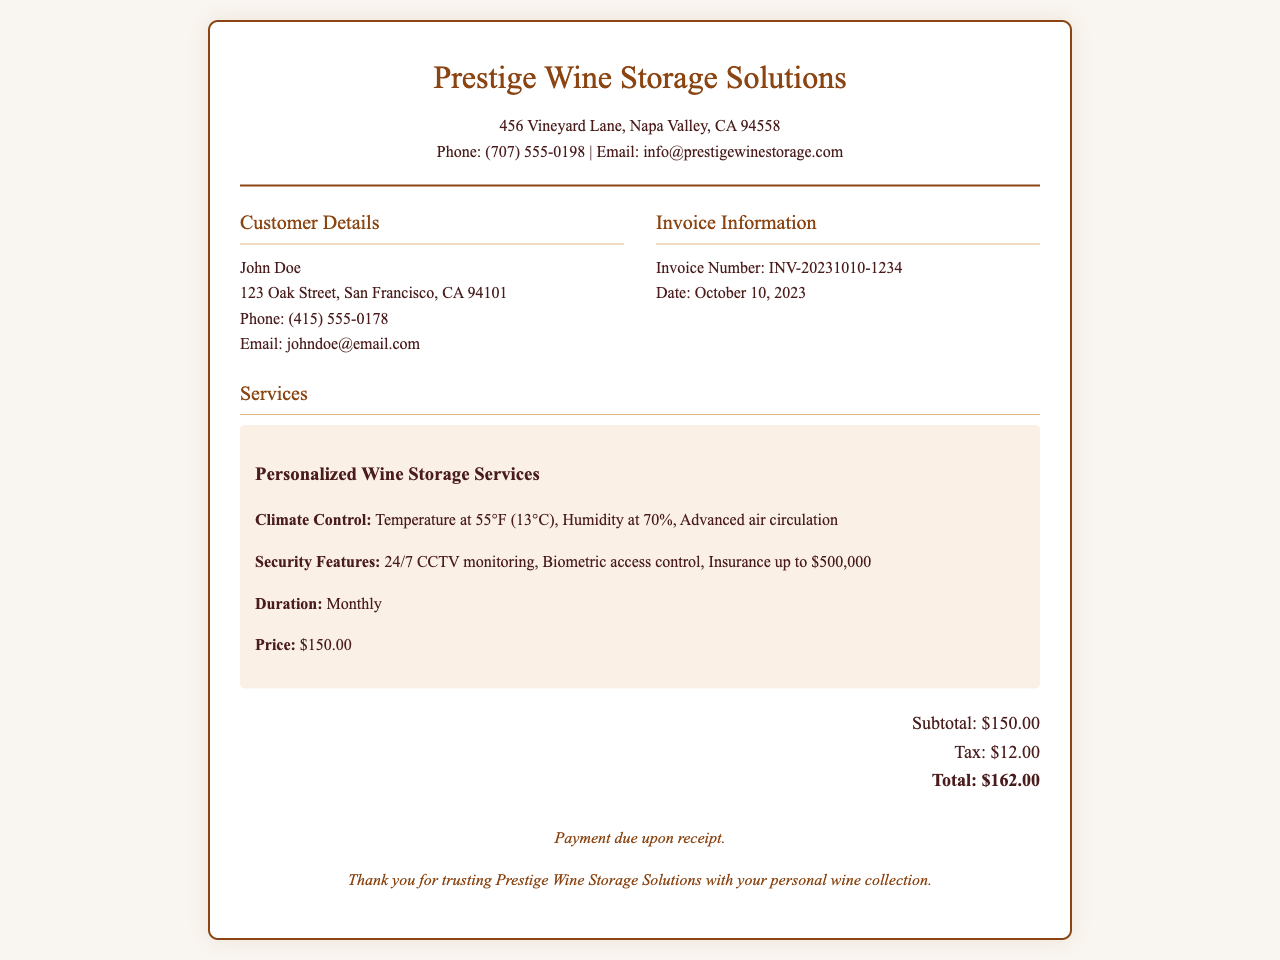What is the name of the company? The company name is listed at the top of the invoice under the company name section.
Answer: Prestige Wine Storage Solutions What is the invoice number? The invoice number is located in the invoice information section under the customer's details.
Answer: INV-20231010-1234 What is the total amount due? The total amount is calculated and listed at the bottom of the invoice in the total amount section.
Answer: $162.00 What is the temperature maintained for climate control? The temperature for climate control is specified in the personalized wine storage services section.
Answer: 55°F What security feature mentioned offers protection for the wine collection? Among the listed security features, one specifically protects the collection and is mentioned in the services section.
Answer: Biometric access control What is the tax amount? The tax amount is provided in the total amount section, beneath the subtotal.
Answer: $12.00 What is the humidity level for the wine storage? The humidity level is mentioned in the climate control details of the services section.
Answer: 70% Who is the customer? The customer’s name is listed in the customer details section of the invoice.
Answer: John Doe 